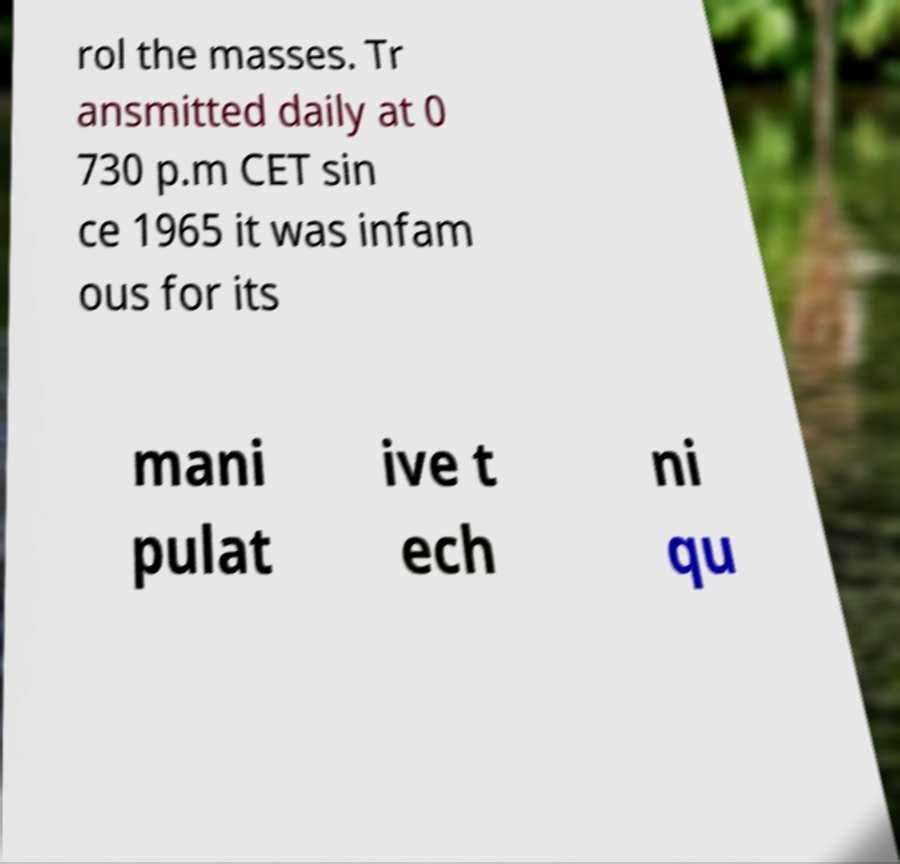What messages or text are displayed in this image? I need them in a readable, typed format. rol the masses. Tr ansmitted daily at 0 730 p.m CET sin ce 1965 it was infam ous for its mani pulat ive t ech ni qu 